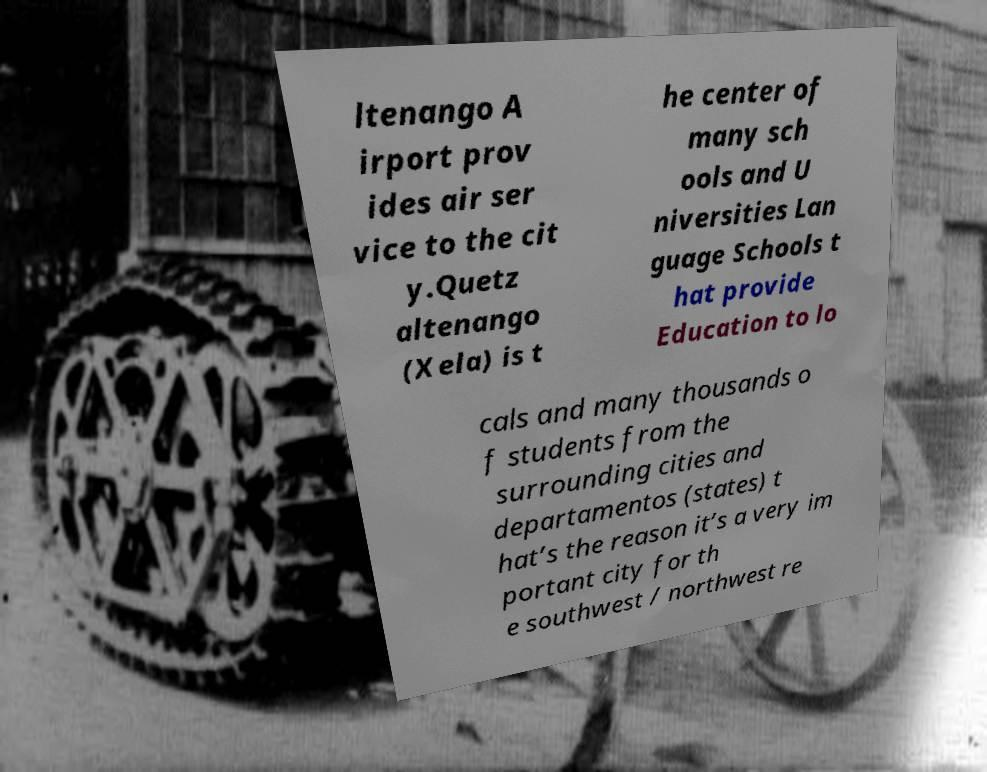Please read and relay the text visible in this image. What does it say? ltenango A irport prov ides air ser vice to the cit y.Quetz altenango (Xela) is t he center of many sch ools and U niversities Lan guage Schools t hat provide Education to lo cals and many thousands o f students from the surrounding cities and departamentos (states) t hat’s the reason it’s a very im portant city for th e southwest / northwest re 